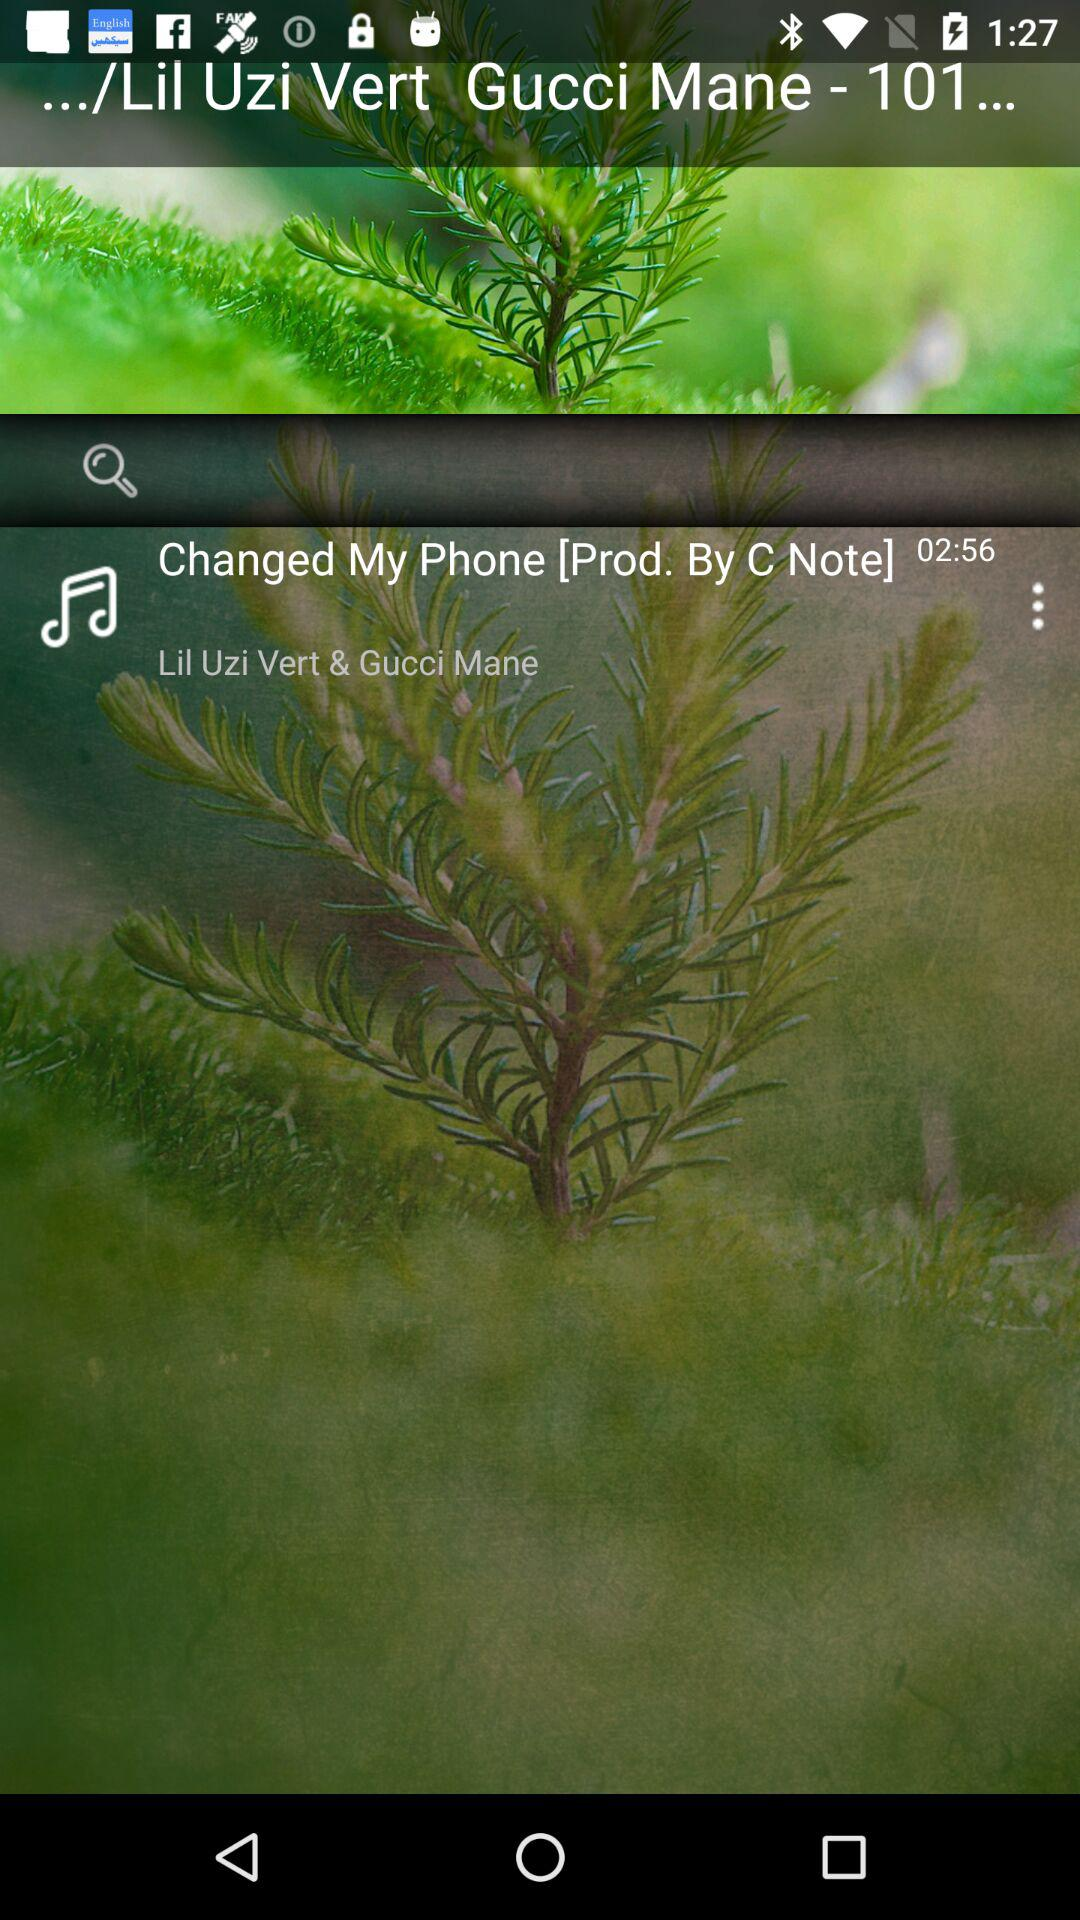What is the duration of the song? The duration of the song is 02:56. 